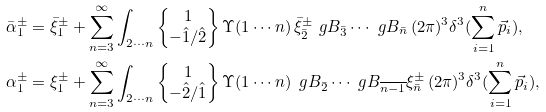Convert formula to latex. <formula><loc_0><loc_0><loc_500><loc_500>\bar { \alpha } ^ { \pm } _ { 1 } & = \bar { \xi } ^ { \pm } _ { 1 } + \sum _ { n = 3 } ^ { \infty } \int _ { 2 \cdots n } \left \{ \begin{matrix} 1 \\ - \hat { 1 } / \hat { 2 } \end{matrix} \right \} \Upsilon ( 1 \cdots n ) \, \bar { \xi } ^ { \pm } _ { \bar { 2 } } \ g B _ { \bar { 3 } } \cdots \ g B _ { \bar { n } } \, ( 2 \pi ) ^ { 3 } \delta ^ { 3 } ( { \sum _ { i = 1 } ^ { n } \vec { p } _ { i } } ) , \\ \alpha ^ { \pm } _ { 1 } & = \xi ^ { \pm } _ { 1 } + \sum _ { n = 3 } ^ { \infty } \int _ { 2 \cdots n } \left \{ \begin{matrix} 1 \\ - \hat { 2 } / \hat { 1 } \end{matrix} \right \} \Upsilon ( 1 \cdots n ) \, \ g B _ { \bar { 2 } } \cdots \ g B _ { \overline { n - 1 } } \xi ^ { \pm } _ { \bar { n } } \, ( 2 \pi ) ^ { 3 } \delta ^ { 3 } ( { \sum _ { i = 1 } ^ { n } \vec { p } _ { i } } ) ,</formula> 